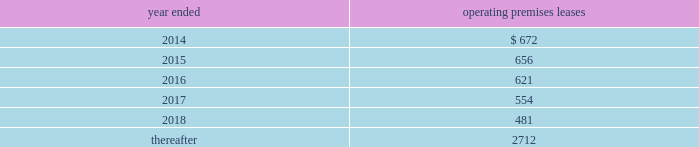Morgan stanley notes to consolidated financial statements 2014 ( continued ) lending commitments .
Primary lending commitments are those that are originated by the company whereas secondary lending commitments are purchased from third parties in the market .
The commitments include lending commitments that are made to investment grade and non-investment grade companies in connection with corporate lending and other business activities .
Commitments for secured lending transactions .
Secured lending commitments are extended by the company to companies and are secured by real estate or other physical assets of the borrower .
Loans made under these arrangements typically are at variable rates and generally provide for over-collateralization based upon the creditworthiness of the borrower .
Forward starting reverse repurchase agreements .
The company has entered into forward starting securities purchased under agreements to resell ( agreements that have a trade date at or prior to december 31 , 2013 and settle subsequent to period-end ) that are primarily secured by collateral from u.s .
Government agency securities and other sovereign government obligations .
Commercial and residential mortgage-related commitments .
The company enters into forward purchase contracts involving residential mortgage loans , residential mortgage lending commitments to individuals and residential home equity lines of credit .
In addition , the company enters into commitments to originate commercial and residential mortgage loans .
Underwriting commitments .
The company provides underwriting commitments in connection with its capital raising sources to a diverse group of corporate and other institutional clients .
Other lending commitments .
Other commitments generally include commercial lending commitments to small businesses and commitments related to securities-based lending activities in connection with the company 2019s wealth management business segment .
The company sponsors several non-consolidated investment funds for third-party investors where the company typically acts as general partner of , and investment advisor to , these funds and typically commits to invest a minority of the capital of such funds , with subscribing third-party investors contributing the majority .
The company 2019s employees , including its senior officers , as well as the company 2019s directors , may participate on the same terms and conditions as other investors in certain of these funds that the company forms primarily for client investment , except that the company may waive or lower applicable fees and charges for its employees .
The company has contractual capital commitments , guarantees , lending facilities and counterparty arrangements with respect to these investment funds .
Premises and equipment .
The company has non-cancelable operating leases covering premises and equipment ( excluding commodities operating leases , shown separately ) .
At december 31 , 2013 , future minimum rental commitments under such leases ( net of subleases , principally on office rentals ) were as follows ( dollars in millions ) : year ended operating premises leases .

What is the percentage difference in future minimum rental commitments as of december 31 , 2013 between 2014 and 2015? 
Computations: ((656 - 672) / 672)
Answer: -0.02381. 